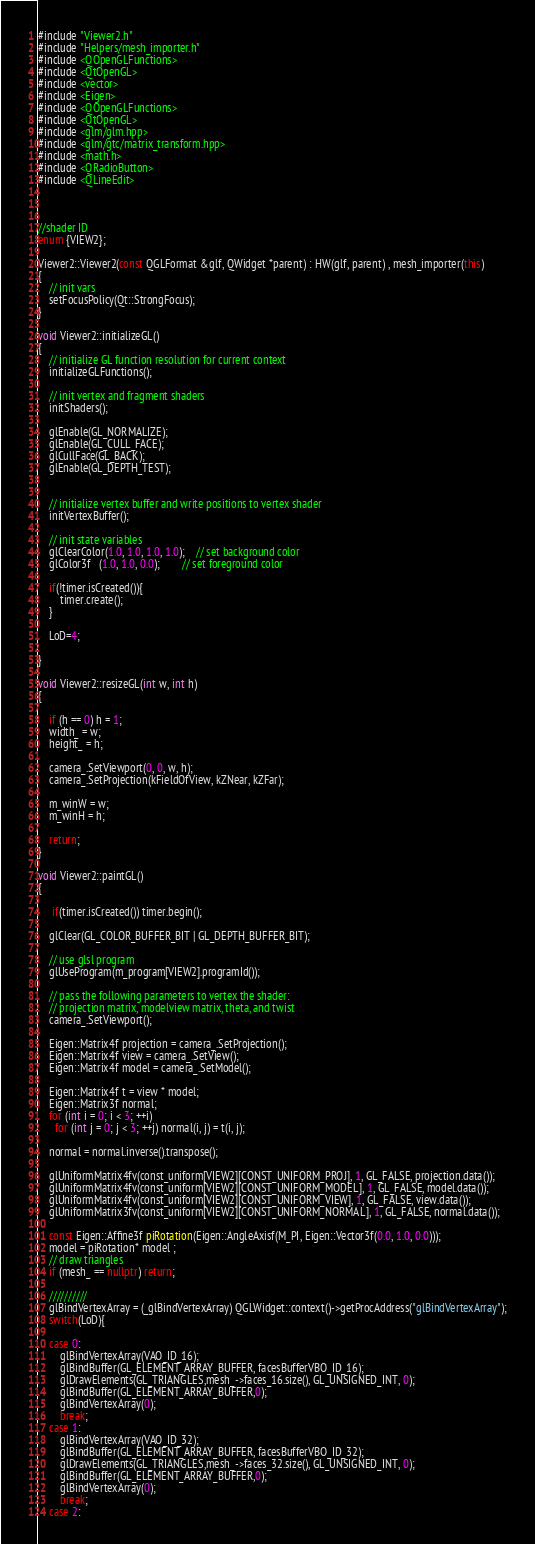Convert code to text. <code><loc_0><loc_0><loc_500><loc_500><_C++_>#include "Viewer2.h"
#include "Helpers/mesh_importer.h"
#include <QOpenGLFunctions>
#include <QtOpenGL>
#include <vector>
#include <Eigen>
#include <QOpenGLFunctions>
#include <QtOpenGL>
#include <glm/glm.hpp>
#include <glm/gtc/matrix_transform.hpp>
#include <math.h>
#include <QRadioButton>
#include <QLineEdit>



//shader ID
enum {VIEW2};

Viewer2::Viewer2(const QGLFormat &glf, QWidget *parent) : HW(glf, parent) , mesh_importer(this)
{
    // init vars
    setFocusPolicy(Qt::StrongFocus);
}

void Viewer2::initializeGL()
{
    // initialize GL function resolution for current context
    initializeGLFunctions();

    // init vertex and fragment shaders
    initShaders();

    glEnable(GL_NORMALIZE);
    glEnable(GL_CULL_FACE);
    glCullFace(GL_BACK);
    glEnable(GL_DEPTH_TEST);


    // initialize vertex buffer and write positions to vertex shader
    initVertexBuffer();

    // init state variables
    glClearColor(1.0, 1.0, 1.0, 1.0);	// set background color
    glColor3f   (1.0, 1.0, 0.0);		// set foreground color

    if(!timer.isCreated()){
        timer.create();
    }

    LoD=4;

}

void Viewer2::resizeGL(int w, int h)
{

    if (h == 0) h = 1;
    width_ = w;
    height_ = h;

    camera_.SetViewport(0, 0, w, h);
    camera_.SetProjection(kFieldOfView, kZNear, kZFar);

    m_winW = w;
    m_winH = h;

    return;
}

void Viewer2::paintGL()
{

     if(timer.isCreated()) timer.begin();

    glClear(GL_COLOR_BUFFER_BIT | GL_DEPTH_BUFFER_BIT);

    // use glsl program
    glUseProgram(m_program[VIEW2].programId());

    // pass the following parameters to vertex the shader:
    // projection matrix, modelview matrix, theta, and twist
    camera_.SetViewport();

    Eigen::Matrix4f projection = camera_.SetProjection();
    Eigen::Matrix4f view = camera_.SetView();
    Eigen::Matrix4f model = camera_.SetModel();

    Eigen::Matrix4f t = view * model;
    Eigen::Matrix3f normal;
    for (int i = 0; i < 3; ++i)
      for (int j = 0; j < 3; ++j) normal(i, j) = t(i, j);

    normal = normal.inverse().transpose();

    glUniformMatrix4fv(const_uniform[VIEW2][CONST_UNIFORM_PROJ], 1, GL_FALSE, projection.data());
    glUniformMatrix4fv(const_uniform[VIEW2][CONST_UNIFORM_MODEL], 1, GL_FALSE, model.data());
    glUniformMatrix4fv(const_uniform[VIEW2][CONST_UNIFORM_VIEW], 1, GL_FALSE, view.data());
    glUniformMatrix3fv(const_uniform[VIEW2][CONST_UNIFORM_NORMAL], 1, GL_FALSE, normal.data());

    const Eigen::Affine3f piRotation(Eigen::AngleAxisf(M_PI, Eigen::Vector3f(0.0, 1.0, 0.0)));
    model = piRotation* model ;
    // draw triangles
    if (mesh_ == nullptr) return;

    //////////
    glBindVertexArray = (_glBindVertexArray) QGLWidget::context()->getProcAddress("glBindVertexArray");
    switch(LoD){

    case 0:
        glBindVertexArray(VAO_ID_16);
        glBindBuffer(GL_ELEMENT_ARRAY_BUFFER, facesBufferVBO_ID_16);
        glDrawElements(GL_TRIANGLES,mesh_->faces_16.size(), GL_UNSIGNED_INT, 0);
        glBindBuffer(GL_ELEMENT_ARRAY_BUFFER,0);
        glBindVertexArray(0);
        break;
    case 1:
        glBindVertexArray(VAO_ID_32);
        glBindBuffer(GL_ELEMENT_ARRAY_BUFFER, facesBufferVBO_ID_32);
        glDrawElements(GL_TRIANGLES,mesh_->faces_32.size(), GL_UNSIGNED_INT, 0);
        glBindBuffer(GL_ELEMENT_ARRAY_BUFFER,0);
        glBindVertexArray(0);
        break;
    case 2:</code> 